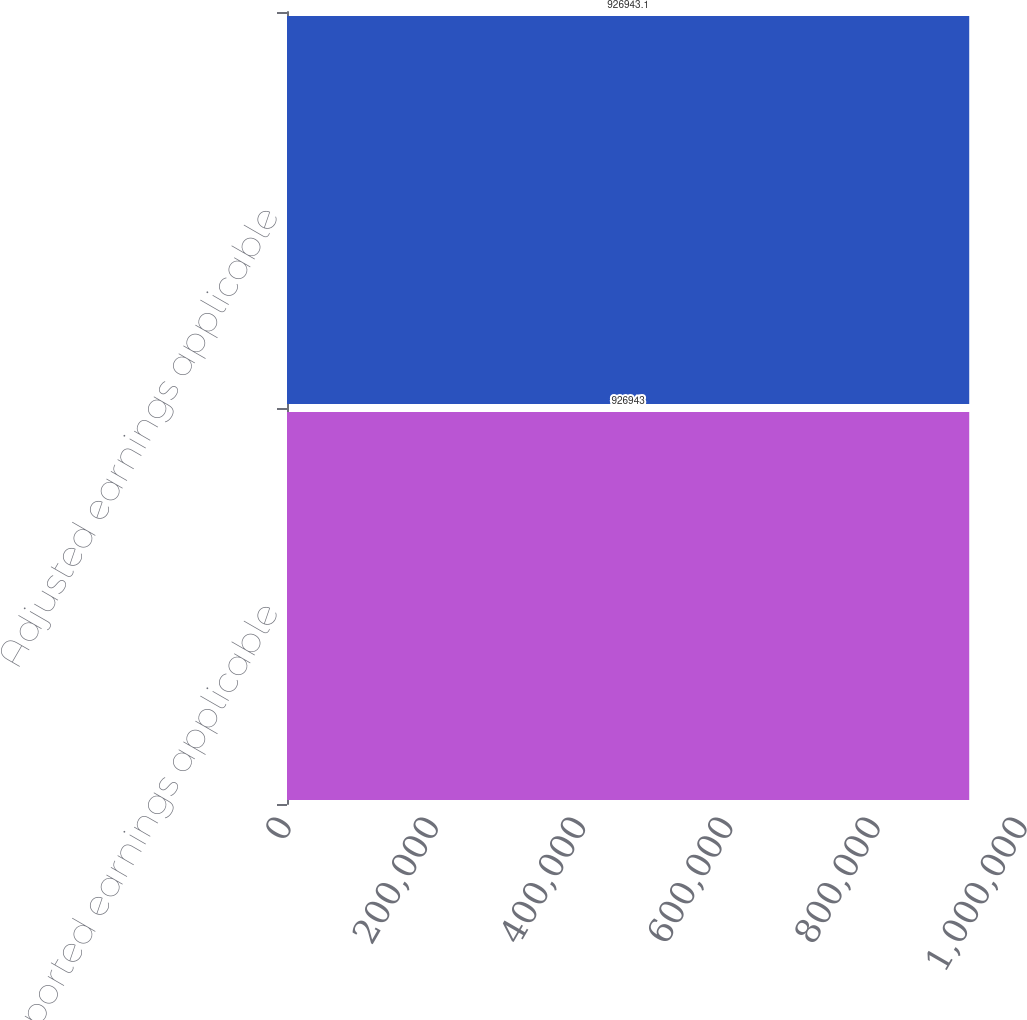Convert chart. <chart><loc_0><loc_0><loc_500><loc_500><bar_chart><fcel>Reported earnings applicable<fcel>Adjusted earnings applicable<nl><fcel>926943<fcel>926943<nl></chart> 